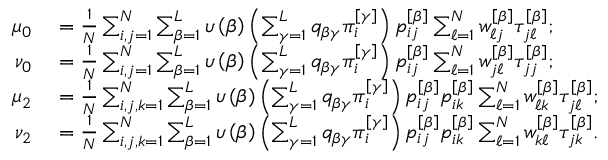Convert formula to latex. <formula><loc_0><loc_0><loc_500><loc_500>\begin{array} { r l } { \mu _ { 0 } } & = \frac { 1 } { N } \sum _ { i , j = 1 } ^ { N } \sum _ { \beta = 1 } ^ { L } \upsilon \left ( \beta \right ) \left ( \sum _ { \gamma = 1 } ^ { L } q _ { \beta \gamma } \pi _ { i } ^ { \left [ \gamma \right ] } \right ) p _ { i j } ^ { \left [ \beta \right ] } \sum _ { \ell = 1 } ^ { N } w _ { \ell j } ^ { \left [ \beta \right ] } \tau _ { j \ell } ^ { \left [ \beta \right ] } ; } \\ { \nu _ { 0 } } & = \frac { 1 } { N } \sum _ { i , j = 1 } ^ { N } \sum _ { \beta = 1 } ^ { L } \upsilon \left ( \beta \right ) \left ( \sum _ { \gamma = 1 } ^ { L } q _ { \beta \gamma } \pi _ { i } ^ { \left [ \gamma \right ] } \right ) p _ { i j } ^ { \left [ \beta \right ] } \sum _ { \ell = 1 } ^ { N } w _ { j \ell } ^ { \left [ \beta \right ] } \tau _ { j j } ^ { \left [ \beta \right ] } ; } \\ { \mu _ { 2 } } & = \frac { 1 } { N } \sum _ { i , j , k = 1 } ^ { N } \sum _ { \beta = 1 } ^ { L } \upsilon \left ( \beta \right ) \left ( \sum _ { \gamma = 1 } ^ { L } q _ { \beta \gamma } \pi _ { i } ^ { \left [ \gamma \right ] } \right ) p _ { i j } ^ { \left [ \beta \right ] } p _ { i k } ^ { \left [ \beta \right ] } \sum _ { \ell = 1 } ^ { N } w _ { \ell k } ^ { \left [ \beta \right ] } \tau _ { j \ell } ^ { \left [ \beta \right ] } ; } \\ { \nu _ { 2 } } & = \frac { 1 } { N } \sum _ { i , j , k = 1 } ^ { N } \sum _ { \beta = 1 } ^ { L } \upsilon \left ( \beta \right ) \left ( \sum _ { \gamma = 1 } ^ { L } q _ { \beta \gamma } \pi _ { i } ^ { \left [ \gamma \right ] } \right ) p _ { i j } ^ { \left [ \beta \right ] } p _ { i k } ^ { \left [ \beta \right ] } \sum _ { \ell = 1 } ^ { N } w _ { k \ell } ^ { \left [ \beta \right ] } \tau _ { j k } ^ { \left [ \beta \right ] } . } \end{array}</formula> 